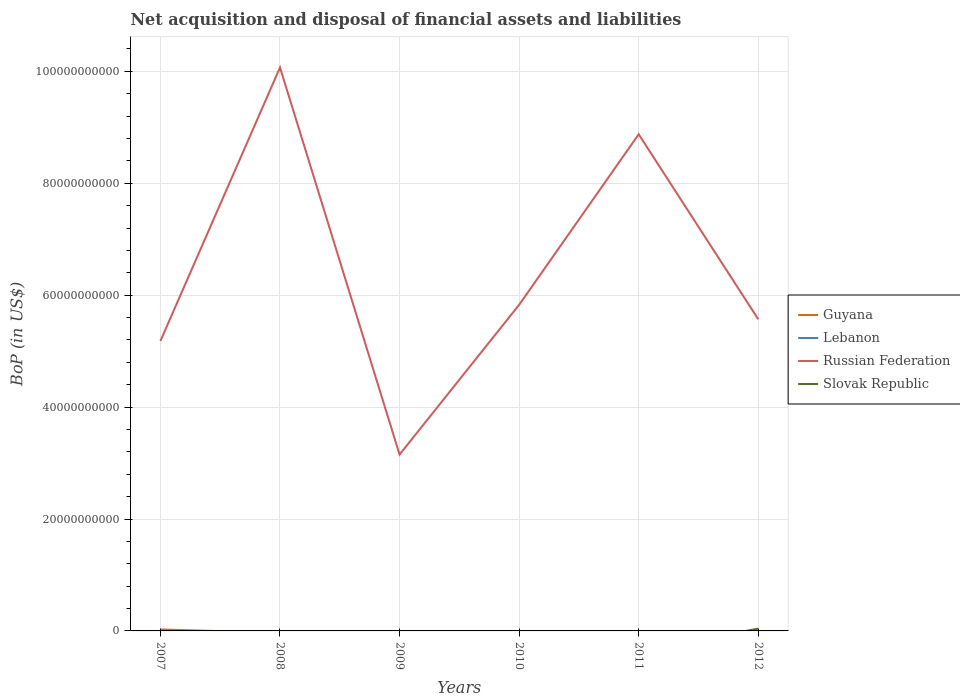Is the number of lines equal to the number of legend labels?
Make the answer very short. No. Across all years, what is the maximum Balance of Payments in Lebanon?
Offer a terse response. 0. What is the total Balance of Payments in Russian Federation in the graph?
Offer a terse response. 4.24e+1. What is the difference between the highest and the second highest Balance of Payments in Russian Federation?
Your answer should be very brief. 6.92e+1. Is the Balance of Payments in Slovak Republic strictly greater than the Balance of Payments in Guyana over the years?
Offer a terse response. No. How many lines are there?
Your answer should be compact. 3. What is the difference between two consecutive major ticks on the Y-axis?
Your answer should be compact. 2.00e+1. Does the graph contain grids?
Ensure brevity in your answer.  Yes. How many legend labels are there?
Give a very brief answer. 4. What is the title of the graph?
Offer a very short reply. Net acquisition and disposal of financial assets and liabilities. What is the label or title of the X-axis?
Offer a very short reply. Years. What is the label or title of the Y-axis?
Make the answer very short. BoP (in US$). What is the BoP (in US$) of Guyana in 2007?
Provide a short and direct response. 2.62e+08. What is the BoP (in US$) of Russian Federation in 2007?
Keep it short and to the point. 5.18e+1. What is the BoP (in US$) of Slovak Republic in 2007?
Your response must be concise. 0. What is the BoP (in US$) in Russian Federation in 2008?
Give a very brief answer. 1.01e+11. What is the BoP (in US$) in Slovak Republic in 2008?
Your response must be concise. 0. What is the BoP (in US$) in Guyana in 2009?
Offer a very short reply. 0. What is the BoP (in US$) in Lebanon in 2009?
Your answer should be very brief. 0. What is the BoP (in US$) of Russian Federation in 2009?
Your answer should be compact. 3.15e+1. What is the BoP (in US$) of Lebanon in 2010?
Provide a short and direct response. 0. What is the BoP (in US$) in Russian Federation in 2010?
Your answer should be very brief. 5.83e+1. What is the BoP (in US$) in Slovak Republic in 2010?
Offer a very short reply. 0. What is the BoP (in US$) in Guyana in 2011?
Make the answer very short. 0. What is the BoP (in US$) of Lebanon in 2011?
Provide a succinct answer. 0. What is the BoP (in US$) in Russian Federation in 2011?
Provide a succinct answer. 8.88e+1. What is the BoP (in US$) of Slovak Republic in 2011?
Ensure brevity in your answer.  0. What is the BoP (in US$) in Guyana in 2012?
Your answer should be very brief. 0. What is the BoP (in US$) of Russian Federation in 2012?
Offer a very short reply. 5.57e+1. What is the BoP (in US$) in Slovak Republic in 2012?
Your response must be concise. 4.13e+08. Across all years, what is the maximum BoP (in US$) of Guyana?
Your response must be concise. 2.62e+08. Across all years, what is the maximum BoP (in US$) in Russian Federation?
Provide a short and direct response. 1.01e+11. Across all years, what is the maximum BoP (in US$) of Slovak Republic?
Your answer should be compact. 4.13e+08. Across all years, what is the minimum BoP (in US$) of Guyana?
Your response must be concise. 0. Across all years, what is the minimum BoP (in US$) in Russian Federation?
Make the answer very short. 3.15e+1. What is the total BoP (in US$) in Guyana in the graph?
Ensure brevity in your answer.  2.62e+08. What is the total BoP (in US$) in Lebanon in the graph?
Give a very brief answer. 0. What is the total BoP (in US$) in Russian Federation in the graph?
Your response must be concise. 3.87e+11. What is the total BoP (in US$) in Slovak Republic in the graph?
Make the answer very short. 4.13e+08. What is the difference between the BoP (in US$) of Russian Federation in 2007 and that in 2008?
Keep it short and to the point. -4.89e+1. What is the difference between the BoP (in US$) of Russian Federation in 2007 and that in 2009?
Keep it short and to the point. 2.03e+1. What is the difference between the BoP (in US$) of Russian Federation in 2007 and that in 2010?
Offer a terse response. -6.46e+09. What is the difference between the BoP (in US$) in Russian Federation in 2007 and that in 2011?
Provide a short and direct response. -3.69e+1. What is the difference between the BoP (in US$) in Russian Federation in 2007 and that in 2012?
Make the answer very short. -3.87e+09. What is the difference between the BoP (in US$) of Russian Federation in 2008 and that in 2009?
Your answer should be very brief. 6.92e+1. What is the difference between the BoP (in US$) of Russian Federation in 2008 and that in 2010?
Ensure brevity in your answer.  4.24e+1. What is the difference between the BoP (in US$) in Russian Federation in 2008 and that in 2011?
Provide a succinct answer. 1.19e+1. What is the difference between the BoP (in US$) of Russian Federation in 2008 and that in 2012?
Provide a succinct answer. 4.50e+1. What is the difference between the BoP (in US$) in Russian Federation in 2009 and that in 2010?
Give a very brief answer. -2.68e+1. What is the difference between the BoP (in US$) in Russian Federation in 2009 and that in 2011?
Keep it short and to the point. -5.72e+1. What is the difference between the BoP (in US$) in Russian Federation in 2009 and that in 2012?
Provide a short and direct response. -2.42e+1. What is the difference between the BoP (in US$) in Russian Federation in 2010 and that in 2011?
Keep it short and to the point. -3.05e+1. What is the difference between the BoP (in US$) in Russian Federation in 2010 and that in 2012?
Offer a very short reply. 2.58e+09. What is the difference between the BoP (in US$) in Russian Federation in 2011 and that in 2012?
Give a very brief answer. 3.31e+1. What is the difference between the BoP (in US$) in Guyana in 2007 and the BoP (in US$) in Russian Federation in 2008?
Provide a short and direct response. -1.00e+11. What is the difference between the BoP (in US$) of Guyana in 2007 and the BoP (in US$) of Russian Federation in 2009?
Offer a very short reply. -3.13e+1. What is the difference between the BoP (in US$) in Guyana in 2007 and the BoP (in US$) in Russian Federation in 2010?
Give a very brief answer. -5.80e+1. What is the difference between the BoP (in US$) in Guyana in 2007 and the BoP (in US$) in Russian Federation in 2011?
Offer a very short reply. -8.85e+1. What is the difference between the BoP (in US$) in Guyana in 2007 and the BoP (in US$) in Russian Federation in 2012?
Offer a terse response. -5.54e+1. What is the difference between the BoP (in US$) of Guyana in 2007 and the BoP (in US$) of Slovak Republic in 2012?
Provide a succinct answer. -1.51e+08. What is the difference between the BoP (in US$) of Russian Federation in 2007 and the BoP (in US$) of Slovak Republic in 2012?
Your answer should be very brief. 5.14e+1. What is the difference between the BoP (in US$) of Russian Federation in 2008 and the BoP (in US$) of Slovak Republic in 2012?
Your response must be concise. 1.00e+11. What is the difference between the BoP (in US$) of Russian Federation in 2009 and the BoP (in US$) of Slovak Republic in 2012?
Offer a terse response. 3.11e+1. What is the difference between the BoP (in US$) in Russian Federation in 2010 and the BoP (in US$) in Slovak Republic in 2012?
Your response must be concise. 5.79e+1. What is the difference between the BoP (in US$) in Russian Federation in 2011 and the BoP (in US$) in Slovak Republic in 2012?
Your answer should be very brief. 8.83e+1. What is the average BoP (in US$) in Guyana per year?
Ensure brevity in your answer.  4.37e+07. What is the average BoP (in US$) of Lebanon per year?
Provide a short and direct response. 0. What is the average BoP (in US$) in Russian Federation per year?
Offer a very short reply. 6.45e+1. What is the average BoP (in US$) of Slovak Republic per year?
Give a very brief answer. 6.88e+07. In the year 2007, what is the difference between the BoP (in US$) in Guyana and BoP (in US$) in Russian Federation?
Give a very brief answer. -5.16e+1. In the year 2012, what is the difference between the BoP (in US$) in Russian Federation and BoP (in US$) in Slovak Republic?
Your response must be concise. 5.53e+1. What is the ratio of the BoP (in US$) of Russian Federation in 2007 to that in 2008?
Provide a succinct answer. 0.51. What is the ratio of the BoP (in US$) of Russian Federation in 2007 to that in 2009?
Make the answer very short. 1.64. What is the ratio of the BoP (in US$) in Russian Federation in 2007 to that in 2010?
Your answer should be compact. 0.89. What is the ratio of the BoP (in US$) in Russian Federation in 2007 to that in 2011?
Give a very brief answer. 0.58. What is the ratio of the BoP (in US$) in Russian Federation in 2007 to that in 2012?
Offer a very short reply. 0.93. What is the ratio of the BoP (in US$) in Russian Federation in 2008 to that in 2009?
Offer a very short reply. 3.19. What is the ratio of the BoP (in US$) in Russian Federation in 2008 to that in 2010?
Provide a short and direct response. 1.73. What is the ratio of the BoP (in US$) in Russian Federation in 2008 to that in 2011?
Your answer should be compact. 1.13. What is the ratio of the BoP (in US$) of Russian Federation in 2008 to that in 2012?
Your response must be concise. 1.81. What is the ratio of the BoP (in US$) of Russian Federation in 2009 to that in 2010?
Your answer should be compact. 0.54. What is the ratio of the BoP (in US$) of Russian Federation in 2009 to that in 2011?
Provide a succinct answer. 0.36. What is the ratio of the BoP (in US$) of Russian Federation in 2009 to that in 2012?
Ensure brevity in your answer.  0.57. What is the ratio of the BoP (in US$) in Russian Federation in 2010 to that in 2011?
Ensure brevity in your answer.  0.66. What is the ratio of the BoP (in US$) of Russian Federation in 2010 to that in 2012?
Ensure brevity in your answer.  1.05. What is the ratio of the BoP (in US$) in Russian Federation in 2011 to that in 2012?
Make the answer very short. 1.59. What is the difference between the highest and the second highest BoP (in US$) of Russian Federation?
Offer a very short reply. 1.19e+1. What is the difference between the highest and the lowest BoP (in US$) of Guyana?
Make the answer very short. 2.62e+08. What is the difference between the highest and the lowest BoP (in US$) of Russian Federation?
Your answer should be compact. 6.92e+1. What is the difference between the highest and the lowest BoP (in US$) in Slovak Republic?
Your response must be concise. 4.13e+08. 